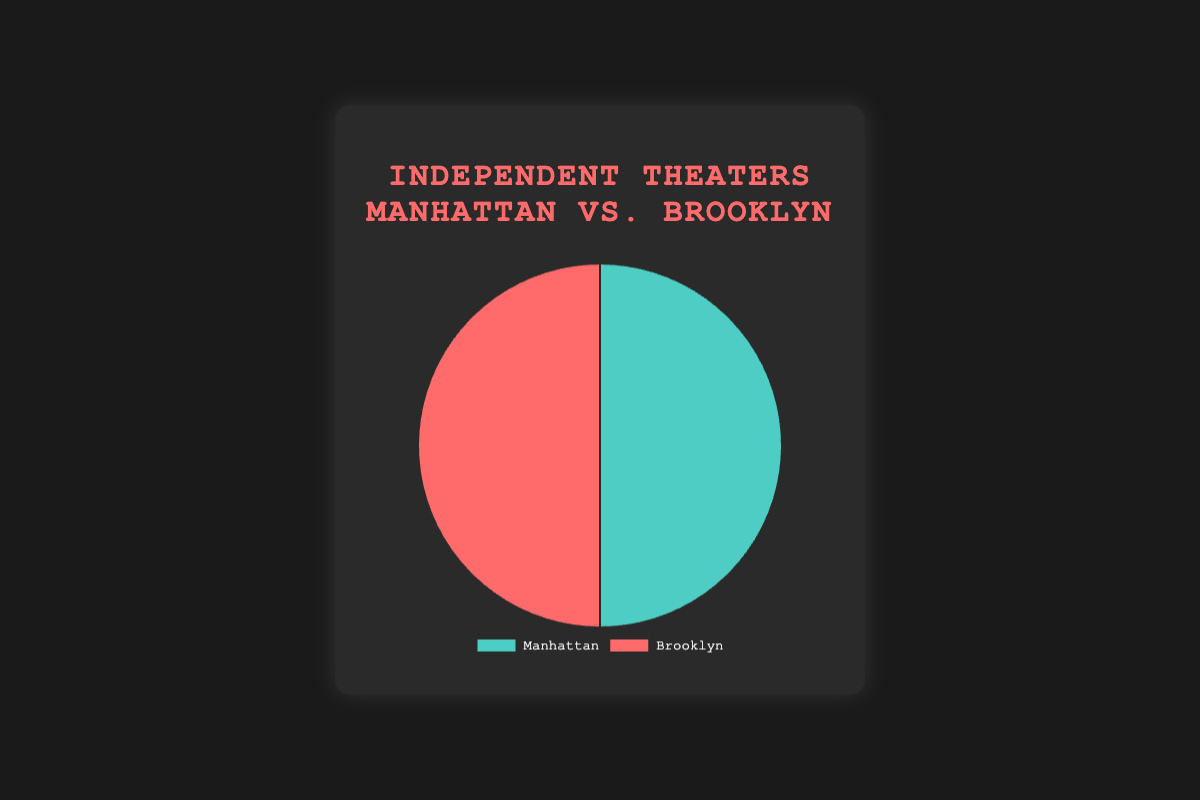What percentage of independent theaters are in Manhattan compared to Brooklyn? The pie chart segments represent Manhattan and Brooklyn, each with an equal number of theaters (10 each). Therefore, the percentage of theaters in Manhattan is (10/(10+10))*100%, which is 50%.
Answer: 50% Which borough has more independent theaters? According to the pie chart, both Manhattan and Brooklyn have the same number of independent theaters. Hence, neither borough has more theaters.
Answer: Neither What is the sum of the independent theaters in both Manhattan and Brooklyn? The sum of independent theaters is the sum of theaters in Manhattan (10) and Brooklyn (10). So, the total number of theaters is 10 + 10.
Answer: 20 If we needed to add one more theater to only one borough to make it have more theaters than the other, which borough should we choose? Since Manhattan and Brooklyn both currently have an equal number of theaters (10), adding one theater to either borough will result in that borough having more theaters. Either one could be chosen.
Answer: Either one What is the proportion of theaters in Brooklyn relative to the total number of theaters in NYC? The proportion can be found by dividing the number of theaters in Brooklyn (10) by the total number of theaters (20). So, the proportion is 10/20 = 0.5.
Answer: 0.5 How different are the counts of independent theaters between Manhattan and Brooklyn? According to the pie chart, both Manhattan and Brooklyn have an equal number of theaters (10 each). Therefore, the difference in their counts is 10 - 10 = 0.
Answer: 0 Which color represents the segment for Brooklyn in the pie chart? The pie chart uses colors to distinguish the segments. Brooklyn is represented by the red color in the pie chart.
Answer: Red Given the sum, how many theaters does each borough contribute to the total? The total number of theaters is 20, and the pie chart shows that Manhattan and Brooklyn each contribute 10 theaters.
Answer: 10 each If one theater were removed from Brooklyn, what percentage of the total would Brooklyn then represent? If Brooklyn had one less theater, it would have 9 theaters. The total number of theaters would then be 10 (Manhattan) + 9 (Brooklyn) = 19. Hence, Brooklyn’s percentage would be (9/19)*100% ≈ 47.37%.
Answer: 47.37% Considering the equal distribution, what strategy can be used to infer any trends about the location preference for independent theaters in NYC? Since both Manhattan and Brooklyn have equal numbers of theaters, one could analyze additional factors, such as the neighborhoods' population density, demographic preferences, and proximity to major cultural hubs to infer trends. Observing whether certain theaters in each borough have higher attendance could also provide insights.
Answer: Analyze additional factors and attendance trends 